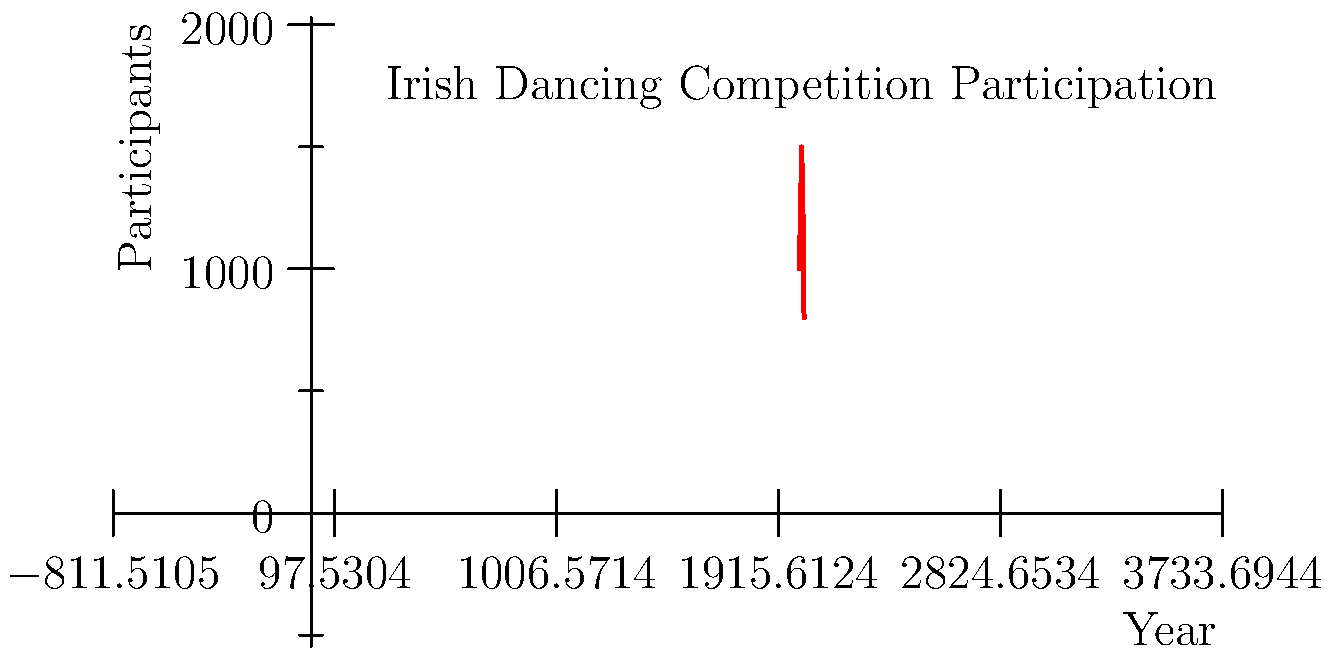Analyzing the line graph depicting Irish dancing competition participation from 2000 to 2020, what significant trend is observed between 2010 and 2020, and how might this relate to changes in local community engagement with traditional Irish culture? To answer this question, we need to analyze the graph step-by-step:

1. Observe the overall trend: The graph shows participation rates in Irish dancing competitions from 2000 to 2020.

2. Identify the peak: Participation reaches its highest point in 2010 with approximately 1500 participants.

3. Focus on the 2010-2020 period:
   a. From 2010 to 2015, there's a decline from about 1500 to 1300 participants.
   b. From 2015 to 2020, there's a steeper decline from about 1300 to 800 participants.

4. Calculate the total decline: From 2010 to 2020, participation dropped by approximately 700 participants (from 1500 to 800).

5. Interpret the trend: This significant decrease suggests a declining interest in Irish dancing competitions over the decade.

6. Relate to local community engagement: As a resident of a rural Irish town, this trend might reflect:
   a. Reduced interest in traditional Irish culture among younger generations.
   b. Fewer local events or resources supporting Irish dancing.
   c. Shift in community priorities or interests away from traditional activities.
   d. Potential economic factors affecting participation in cultural events.

The significant downward trend from 2010 to 2020 indicates a substantial decrease in Irish dancing competition participation, potentially reflecting changing attitudes towards traditional Irish culture in local communities.
Answer: Significant decrease in participation, suggesting declining local engagement with traditional Irish culture. 